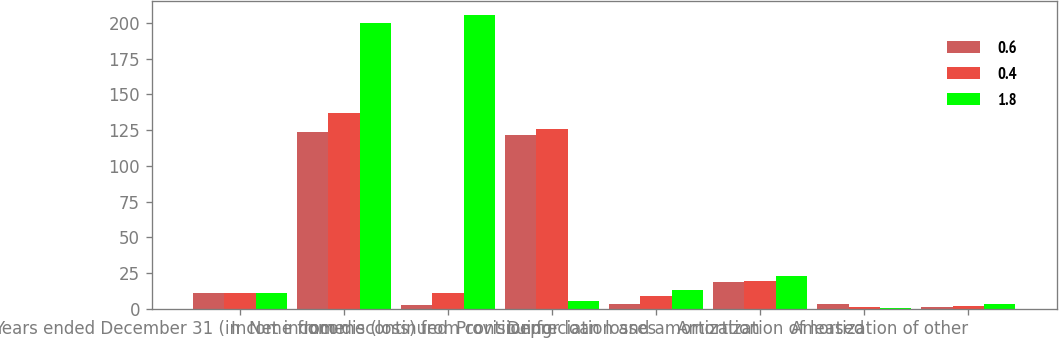<chart> <loc_0><loc_0><loc_500><loc_500><stacked_bar_chart><ecel><fcel>Years ended December 31 (in<fcel>Net income<fcel>Income from discontinued<fcel>Income (loss) from continuing<fcel>Provision for loan losses<fcel>Depreciation and amortization<fcel>Amortization of leased<fcel>Amortization of other<nl><fcel>0.6<fcel>11.2<fcel>124<fcel>2.3<fcel>121.7<fcel>3.4<fcel>19<fcel>3.3<fcel>1.1<nl><fcel>0.4<fcel>11.2<fcel>137.1<fcel>11.2<fcel>125.9<fcel>8.6<fcel>19.7<fcel>1.3<fcel>1.8<nl><fcel>1.8<fcel>11.2<fcel>199.7<fcel>205.3<fcel>5.6<fcel>13.3<fcel>22.9<fcel>0.7<fcel>3.4<nl></chart> 